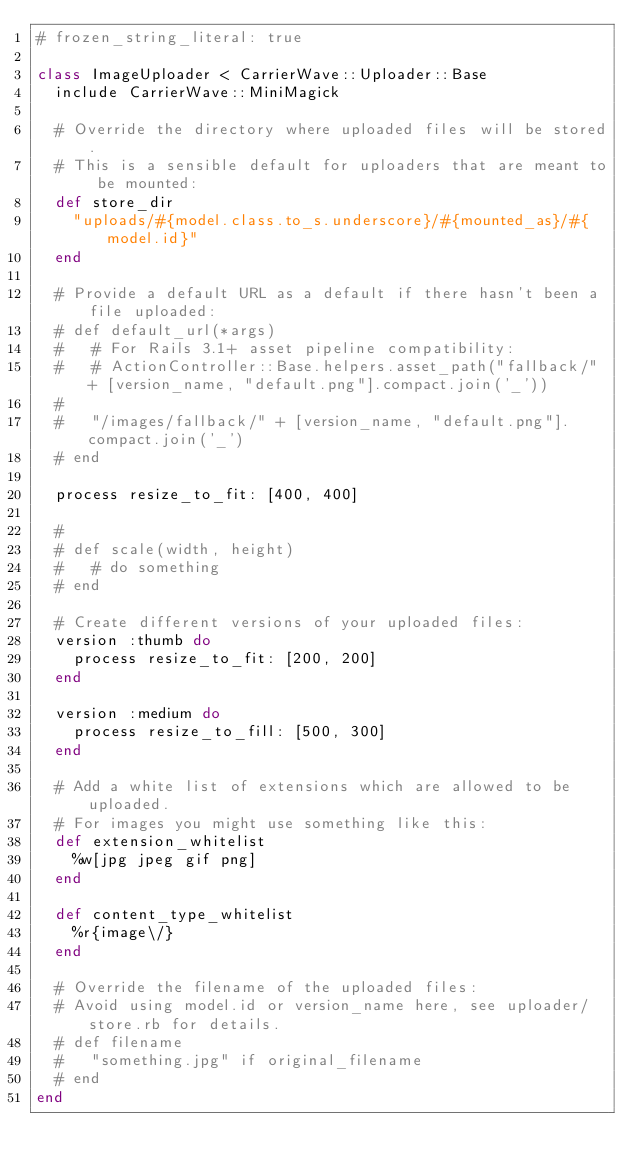Convert code to text. <code><loc_0><loc_0><loc_500><loc_500><_Ruby_># frozen_string_literal: true

class ImageUploader < CarrierWave::Uploader::Base
  include CarrierWave::MiniMagick

  # Override the directory where uploaded files will be stored.
  # This is a sensible default for uploaders that are meant to be mounted:
  def store_dir
    "uploads/#{model.class.to_s.underscore}/#{mounted_as}/#{model.id}"
  end

  # Provide a default URL as a default if there hasn't been a file uploaded:
  # def default_url(*args)
  #   # For Rails 3.1+ asset pipeline compatibility:
  #   # ActionController::Base.helpers.asset_path("fallback/" + [version_name, "default.png"].compact.join('_'))
  #
  #   "/images/fallback/" + [version_name, "default.png"].compact.join('_')
  # end

  process resize_to_fit: [400, 400]

  #
  # def scale(width, height)
  #   # do something
  # end

  # Create different versions of your uploaded files:
  version :thumb do
    process resize_to_fit: [200, 200]
  end

  version :medium do
    process resize_to_fill: [500, 300]
  end

  # Add a white list of extensions which are allowed to be uploaded.
  # For images you might use something like this:
  def extension_whitelist
    %w[jpg jpeg gif png]
  end

  def content_type_whitelist
    %r{image\/}
  end

  # Override the filename of the uploaded files:
  # Avoid using model.id or version_name here, see uploader/store.rb for details.
  # def filename
  #   "something.jpg" if original_filename
  # end
end
</code> 